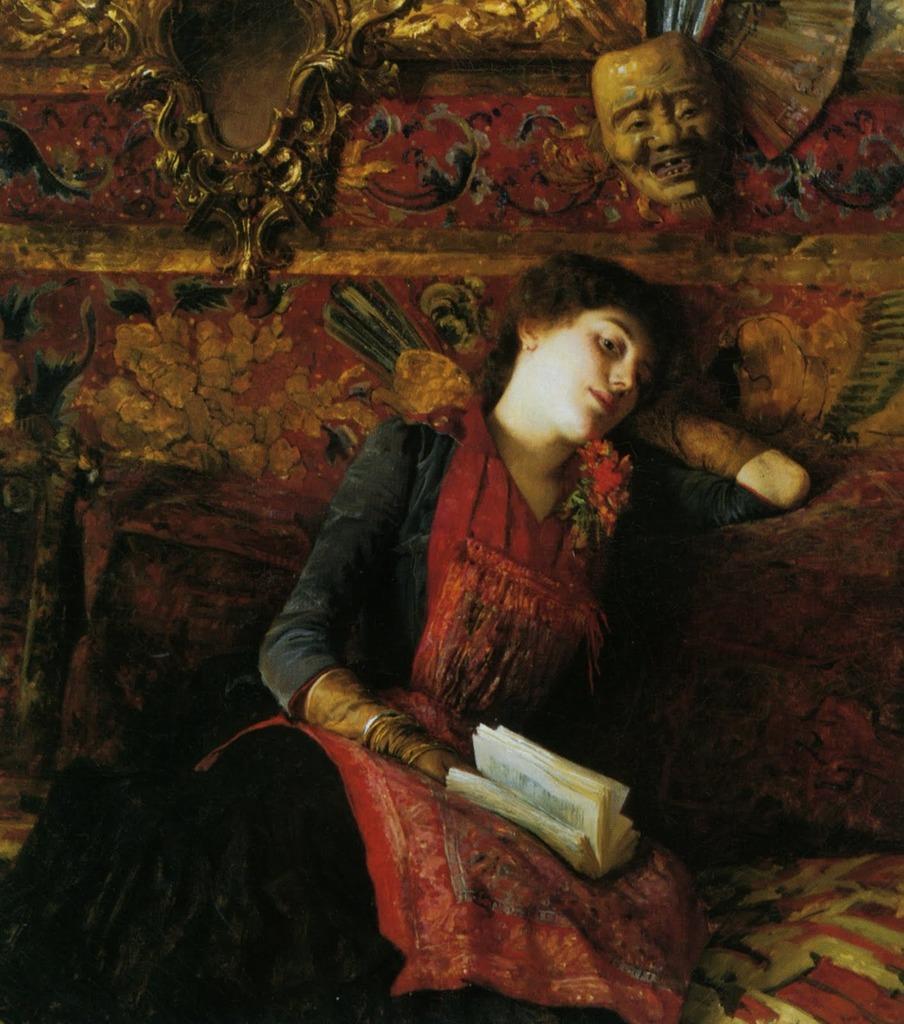Could you give a brief overview of what you see in this image? In this picture we can see a woman sitting and holding a book in her hand. On the background of the picture we can see a mask of a person. This is completely an animated picture. 